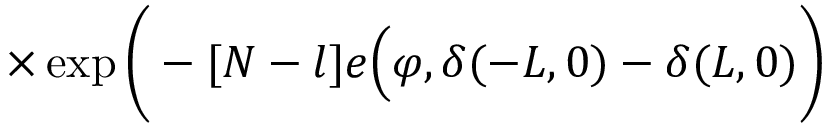Convert formula to latex. <formula><loc_0><loc_0><loc_500><loc_500>\times \exp \Big ( - [ N - l ] e \Big ( \varphi , \delta ( - L , 0 ) - \delta ( L , 0 ) \Big )</formula> 